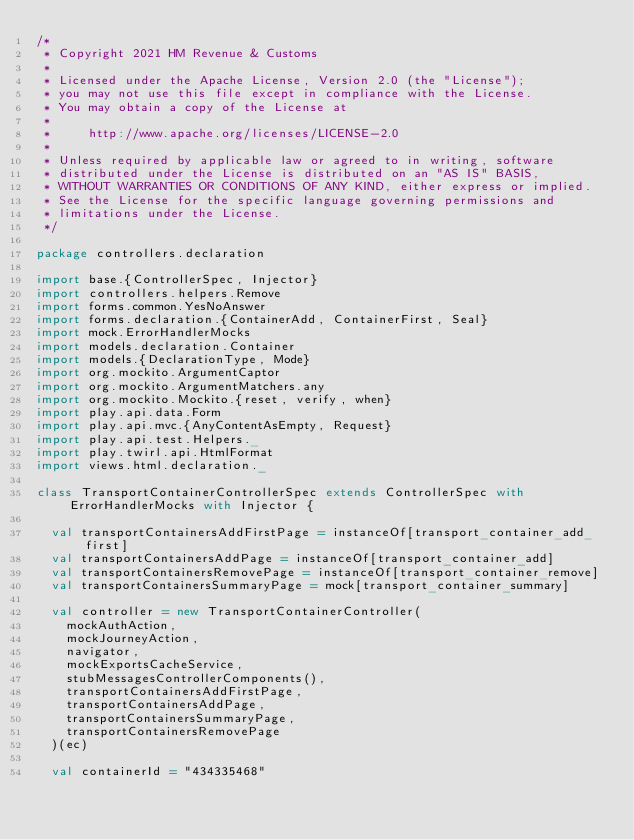<code> <loc_0><loc_0><loc_500><loc_500><_Scala_>/*
 * Copyright 2021 HM Revenue & Customs
 *
 * Licensed under the Apache License, Version 2.0 (the "License");
 * you may not use this file except in compliance with the License.
 * You may obtain a copy of the License at
 *
 *     http://www.apache.org/licenses/LICENSE-2.0
 *
 * Unless required by applicable law or agreed to in writing, software
 * distributed under the License is distributed on an "AS IS" BASIS,
 * WITHOUT WARRANTIES OR CONDITIONS OF ANY KIND, either express or implied.
 * See the License for the specific language governing permissions and
 * limitations under the License.
 */

package controllers.declaration

import base.{ControllerSpec, Injector}
import controllers.helpers.Remove
import forms.common.YesNoAnswer
import forms.declaration.{ContainerAdd, ContainerFirst, Seal}
import mock.ErrorHandlerMocks
import models.declaration.Container
import models.{DeclarationType, Mode}
import org.mockito.ArgumentCaptor
import org.mockito.ArgumentMatchers.any
import org.mockito.Mockito.{reset, verify, when}
import play.api.data.Form
import play.api.mvc.{AnyContentAsEmpty, Request}
import play.api.test.Helpers._
import play.twirl.api.HtmlFormat
import views.html.declaration._

class TransportContainerControllerSpec extends ControllerSpec with ErrorHandlerMocks with Injector {

  val transportContainersAddFirstPage = instanceOf[transport_container_add_first]
  val transportContainersAddPage = instanceOf[transport_container_add]
  val transportContainersRemovePage = instanceOf[transport_container_remove]
  val transportContainersSummaryPage = mock[transport_container_summary]

  val controller = new TransportContainerController(
    mockAuthAction,
    mockJourneyAction,
    navigator,
    mockExportsCacheService,
    stubMessagesControllerComponents(),
    transportContainersAddFirstPage,
    transportContainersAddPage,
    transportContainersSummaryPage,
    transportContainersRemovePage
  )(ec)

  val containerId = "434335468"</code> 